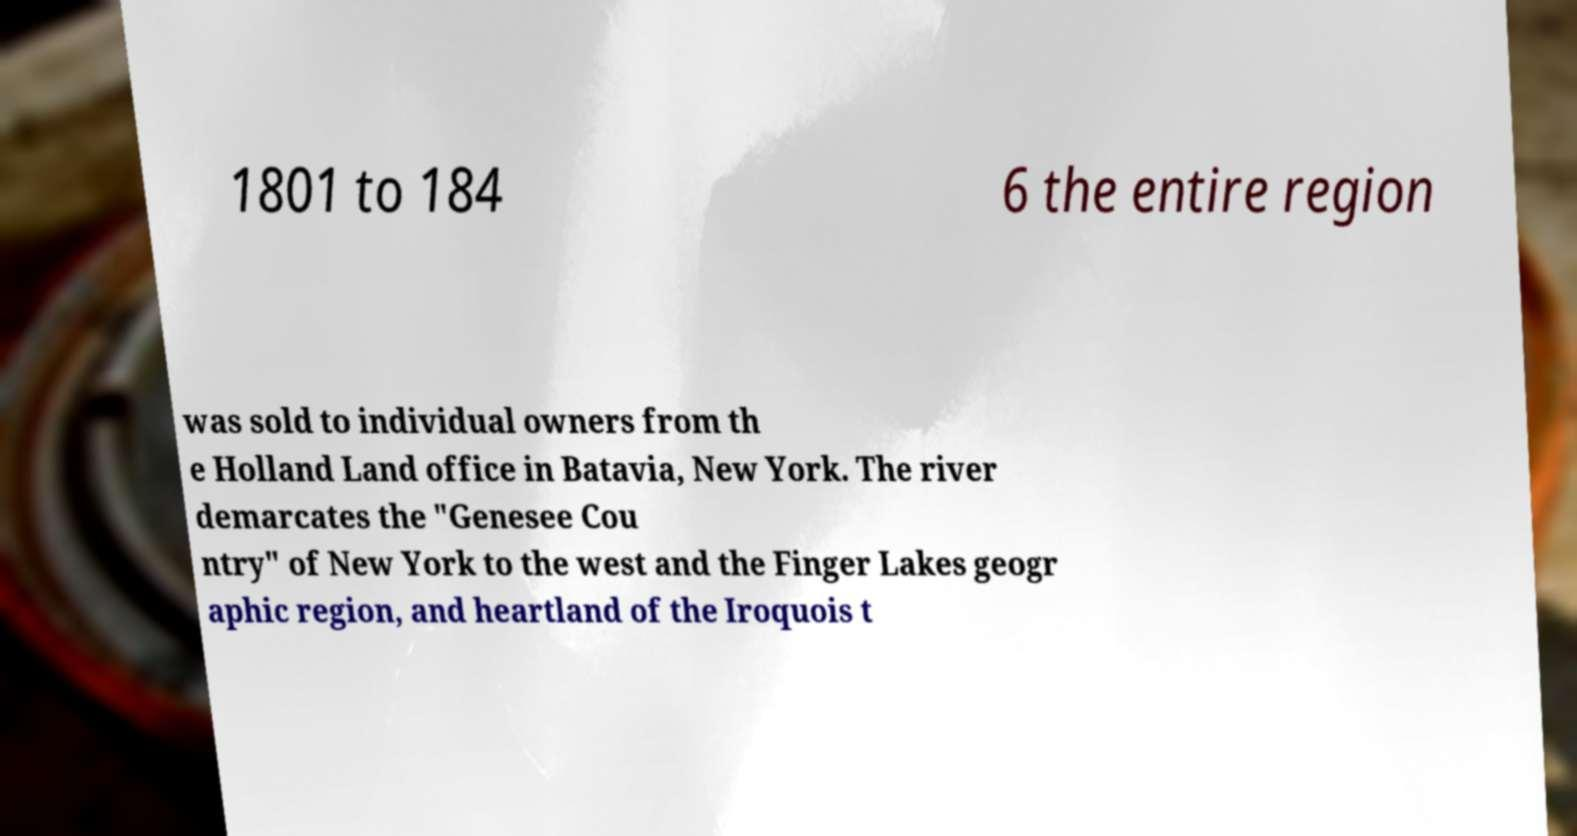Please read and relay the text visible in this image. What does it say? 1801 to 184 6 the entire region was sold to individual owners from th e Holland Land office in Batavia, New York. The river demarcates the "Genesee Cou ntry" of New York to the west and the Finger Lakes geogr aphic region, and heartland of the Iroquois t 